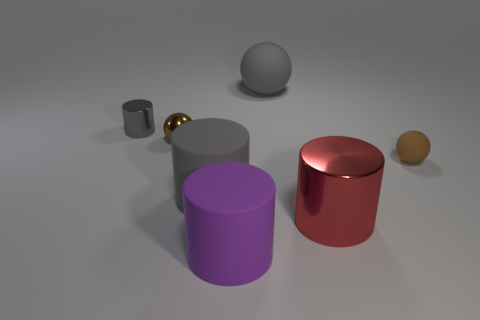Subtract all tiny brown shiny spheres. How many spheres are left? 2 Add 3 small things. How many objects exist? 10 Subtract all gray spheres. How many spheres are left? 2 Add 6 big gray metal objects. How many big gray metal objects exist? 6 Subtract 0 blue cylinders. How many objects are left? 7 Subtract all spheres. How many objects are left? 4 Subtract 1 balls. How many balls are left? 2 Subtract all green balls. Subtract all green cylinders. How many balls are left? 3 Subtract all gray blocks. How many gray cylinders are left? 2 Subtract all large matte spheres. Subtract all red metallic cylinders. How many objects are left? 5 